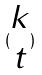<formula> <loc_0><loc_0><loc_500><loc_500>( \begin{matrix} k \\ t \end{matrix} )</formula> 